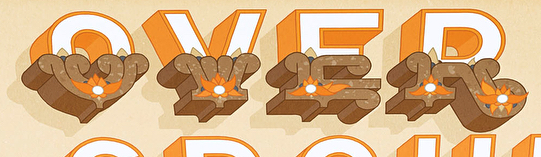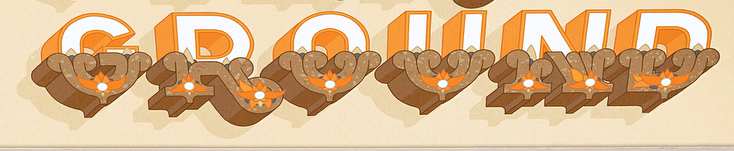Read the text content from these images in order, separated by a semicolon. OVER; GROUND 